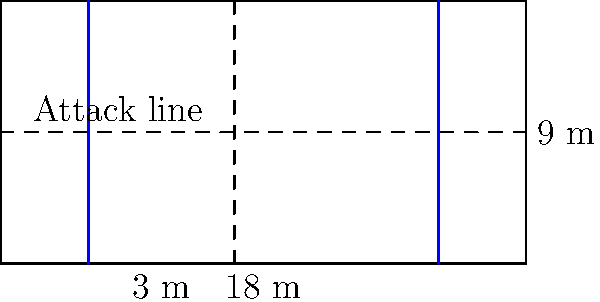You're designing a volleyball court for your local team's practice. The standard court dimensions are 18 meters long and 9 meters wide, with attack lines 3 meters from each end of the court. What is the total area of the volleyball court in square meters? Let's approach this step-by-step:

1. The volleyball court is a rectangle.
2. The formula for the area of a rectangle is: $A = l \times w$
   Where $A$ is the area, $l$ is the length, and $w$ is the width.

3. We are given:
   Length $(l) = 18$ meters
   Width $(w) = 9$ meters

4. Let's substitute these values into our formula:
   $A = 18 \times 9$

5. Now, let's calculate:
   $A = 162$ square meters

Therefore, the total area of the volleyball court is 162 square meters.

Note: The attack lines don't affect the total area calculation, as they are just markings within the court.
Answer: 162 m² 